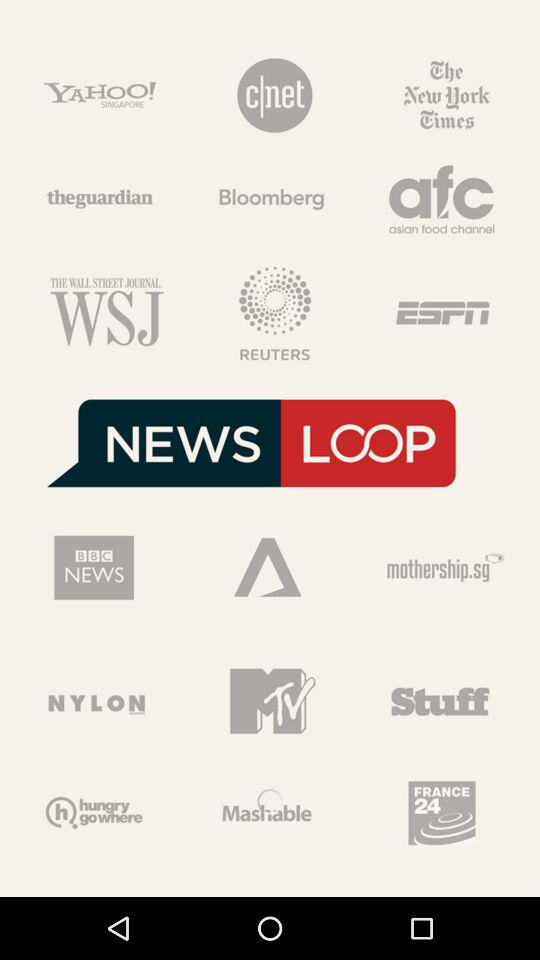How many news channels are on the first page?
Answer the question using a single word or phrase. 9 